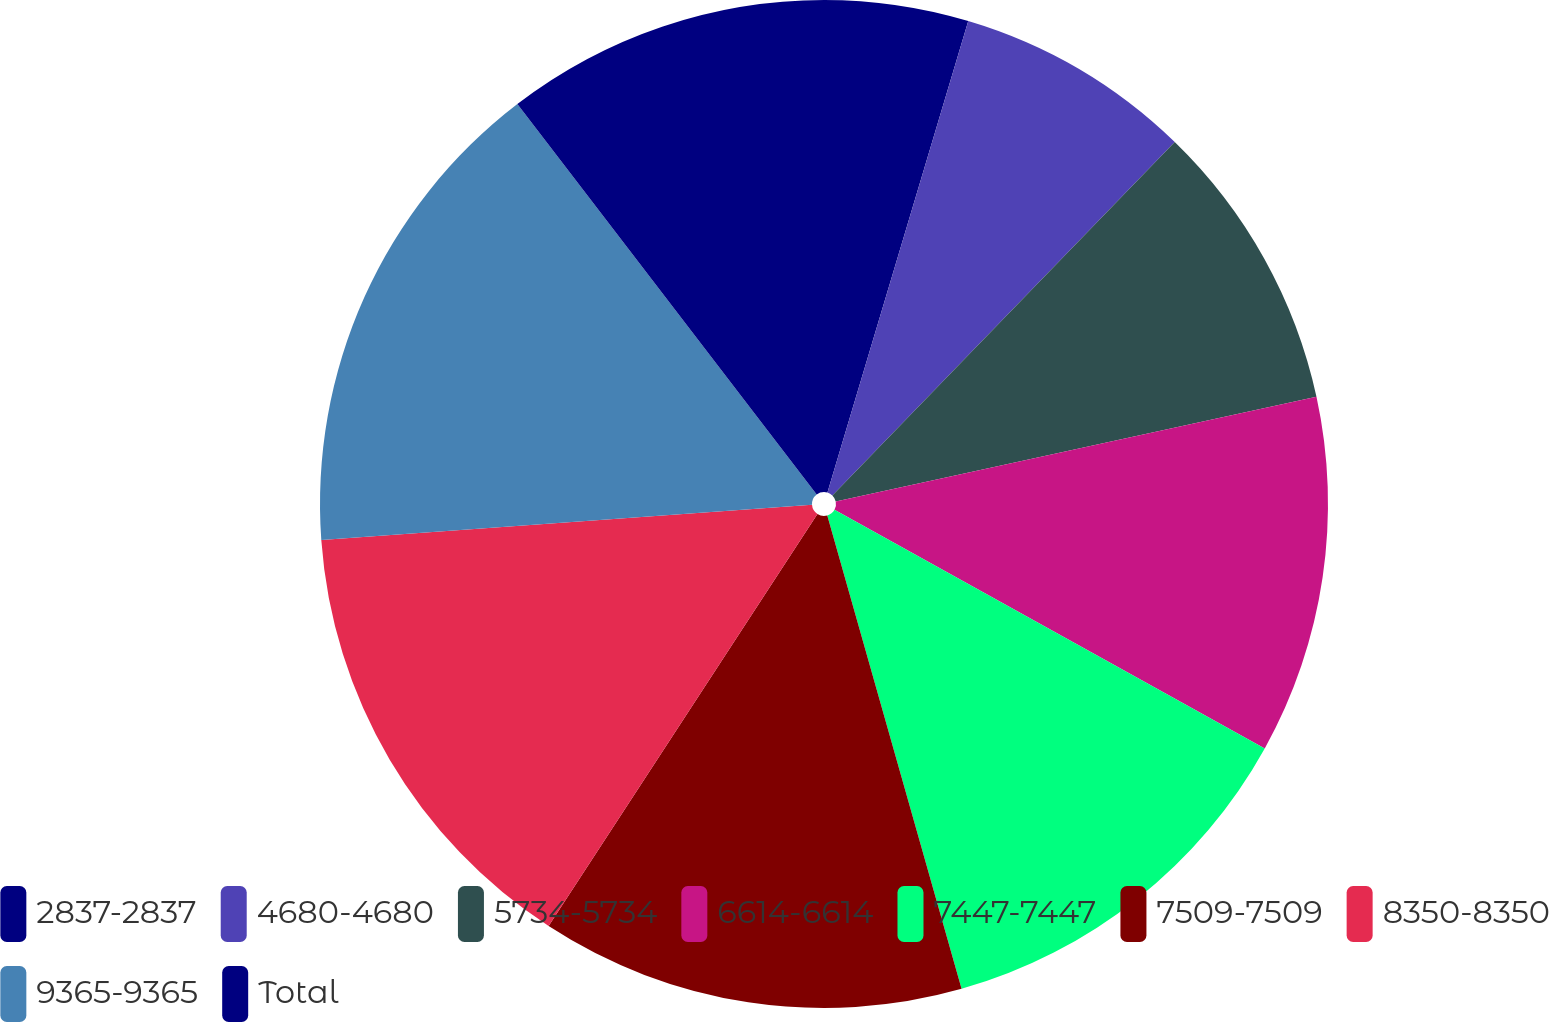Convert chart to OTSL. <chart><loc_0><loc_0><loc_500><loc_500><pie_chart><fcel>2837-2837<fcel>4680-4680<fcel>5734-5734<fcel>6614-6614<fcel>7447-7447<fcel>7509-7509<fcel>8350-8350<fcel>9365-9365<fcel>Total<nl><fcel>4.62%<fcel>7.63%<fcel>9.34%<fcel>11.47%<fcel>12.54%<fcel>13.6%<fcel>14.66%<fcel>15.73%<fcel>10.41%<nl></chart> 